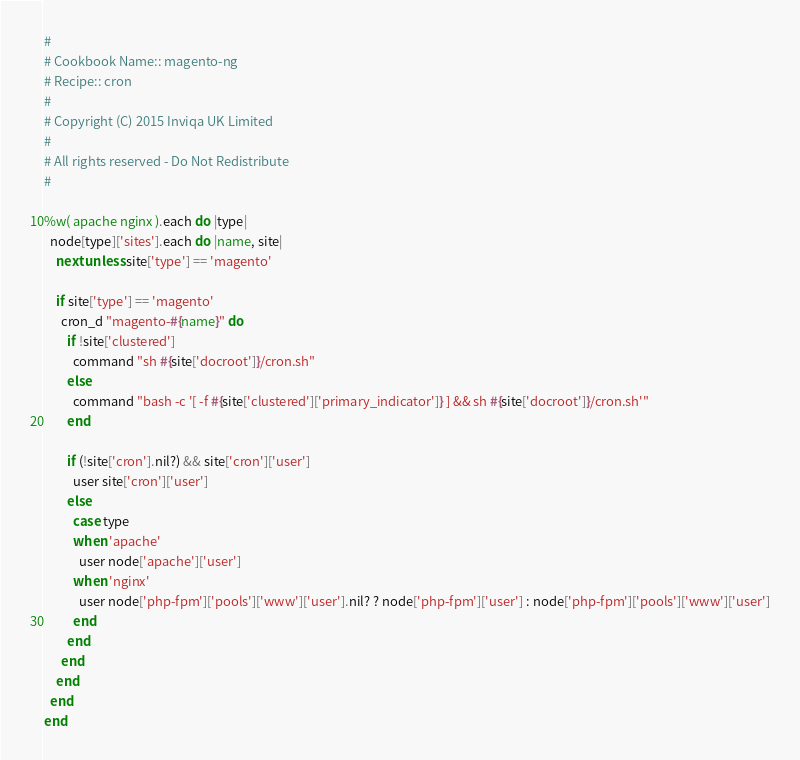<code> <loc_0><loc_0><loc_500><loc_500><_Ruby_>#
# Cookbook Name:: magento-ng
# Recipe:: cron
#
# Copyright (C) 2015 Inviqa UK Limited
#
# All rights reserved - Do Not Redistribute
#

%w( apache nginx ).each do |type|
  node[type]['sites'].each do |name, site|
    next unless site['type'] == 'magento'

    if site['type'] == 'magento'
      cron_d "magento-#{name}" do
        if !site['clustered']
          command "sh #{site['docroot']}/cron.sh"
        else
          command "bash -c '[ -f #{site['clustered']['primary_indicator']} ] && sh #{site['docroot']}/cron.sh'"
        end

        if (!site['cron'].nil?) && site['cron']['user']
          user site['cron']['user']
        else
          case type
          when 'apache'
            user node['apache']['user']
          when 'nginx'
            user node['php-fpm']['pools']['www']['user'].nil? ? node['php-fpm']['user'] : node['php-fpm']['pools']['www']['user']
          end
        end
      end
    end
  end
end</code> 